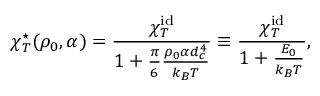Convert formula to latex. <formula><loc_0><loc_0><loc_500><loc_500>\chi _ { T } ^ { ^ { * } } ( \rho _ { 0 } , \alpha ) = \frac { \chi _ { T } ^ { i d } } { 1 + \frac { \pi } { 6 } \frac { \rho _ { 0 } \alpha d _ { c } ^ { 4 } } { k _ { B } T } } \equiv \frac { \chi _ { T } ^ { i d } } { 1 + \frac { E _ { 0 } } { k _ { B } T } } ,</formula> 